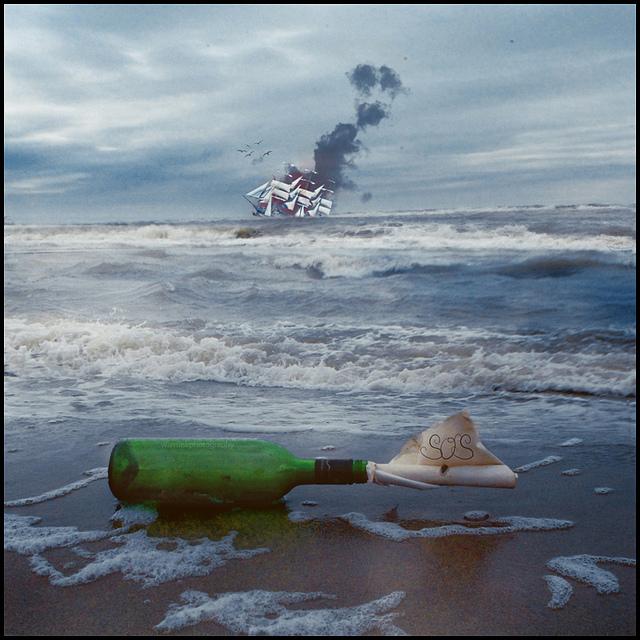What does the note in the bottle say?
Write a very short answer. Sos. What color is the bottle?
Answer briefly. Green. What is the ship doing?
Be succinct. Sinking. 